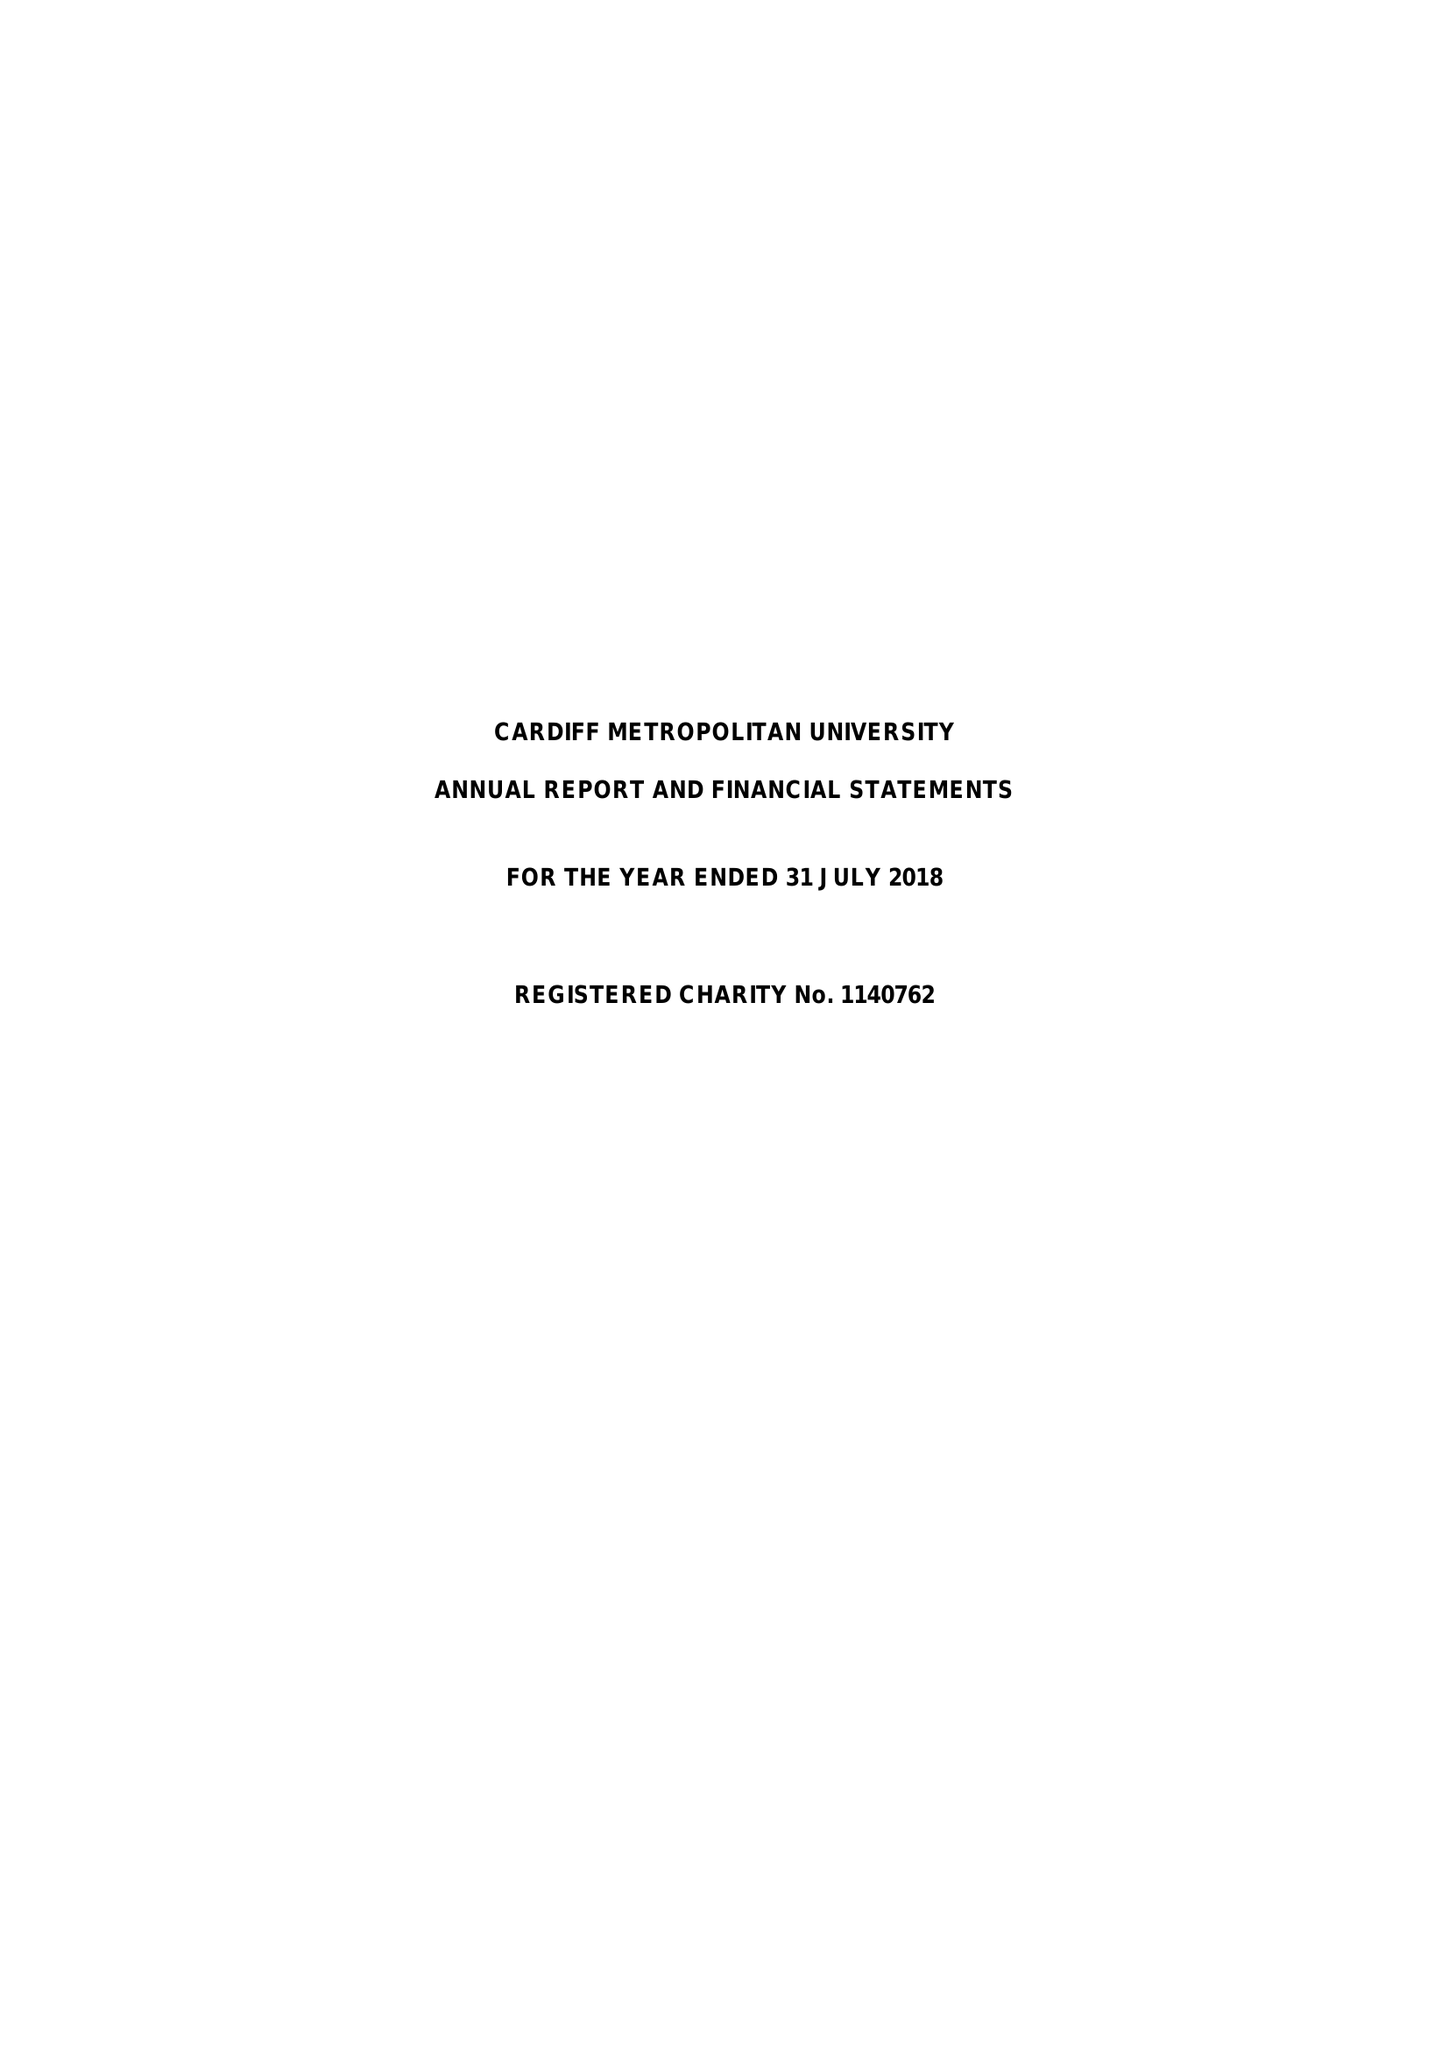What is the value for the report_date?
Answer the question using a single word or phrase. 2018-07-31 